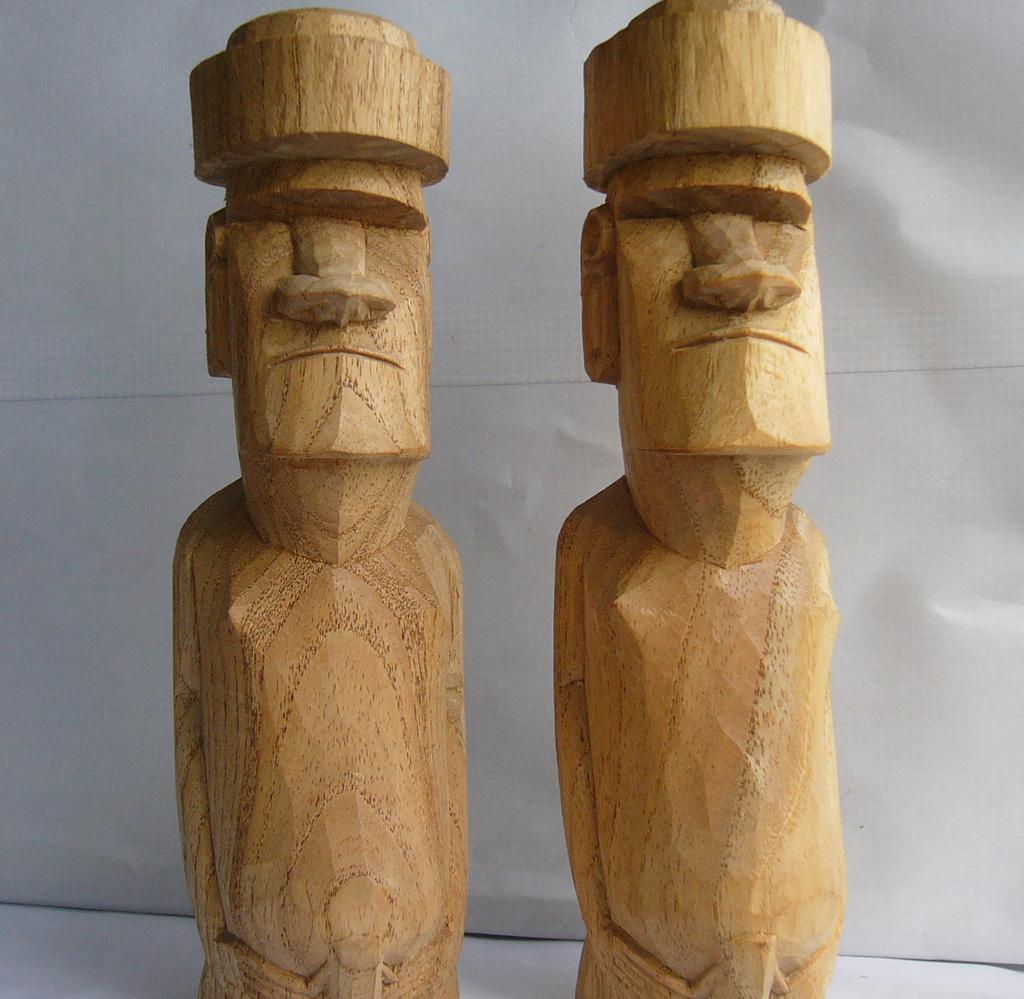What is the color of the wall in the image? The wall in the image is white. What type of objects are made with wood in the image? There are human statues made with wood in the image. Can you see a gun in the image? No, there is no gun present in the image. Are there any visible ears on the wooden human statues? The wooden human statues do not have visible ears in the image. 